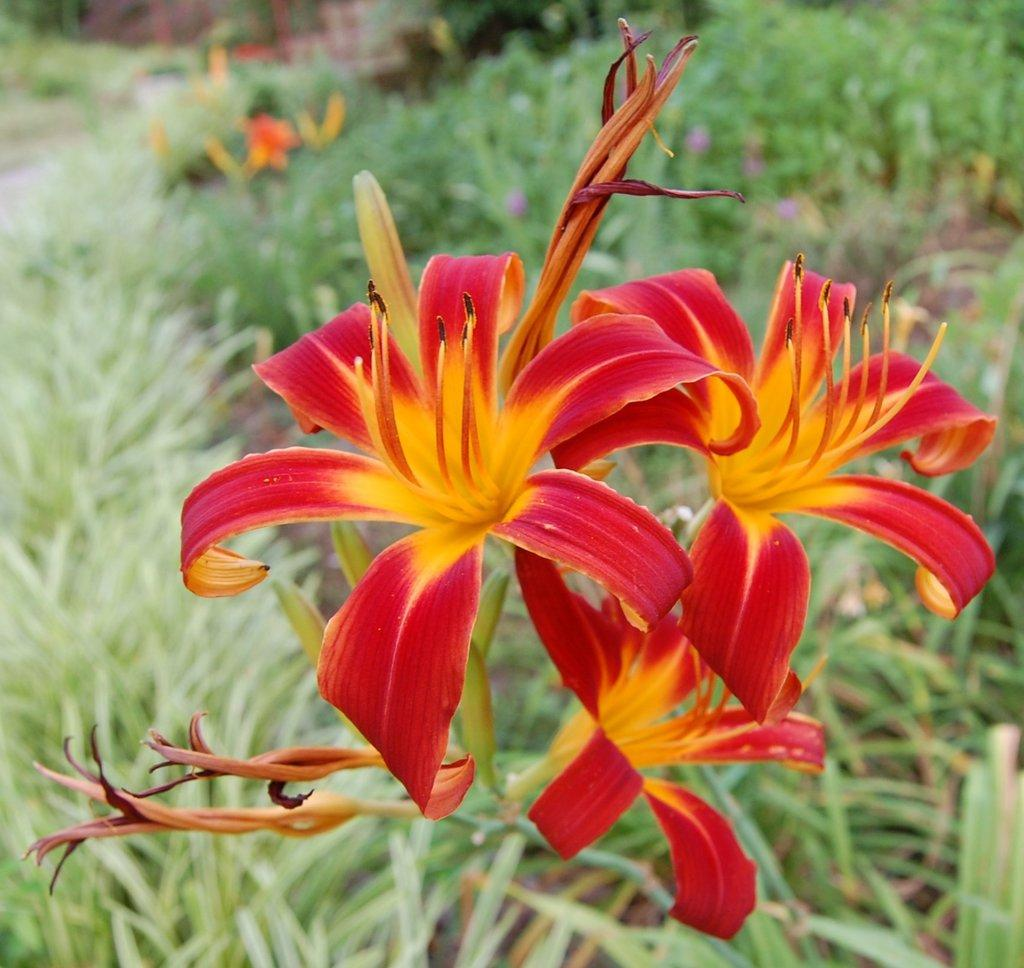What type of living organisms can be seen in the image? There are flowers in the image. What can be seen in the background of the image? There are plants in the background of the image. What type of haircut is the flower receiving in the image? There is no haircut present in the image, as flowers do not have hair. 